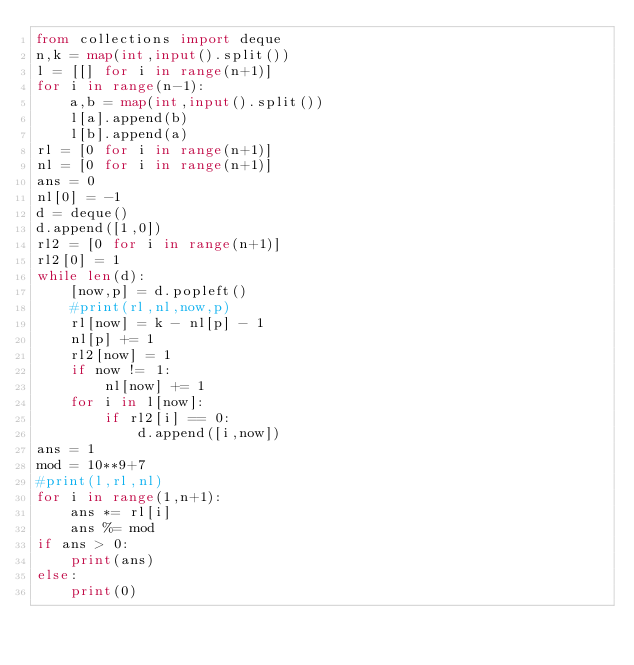<code> <loc_0><loc_0><loc_500><loc_500><_Python_>from collections import deque
n,k = map(int,input().split())
l = [[] for i in range(n+1)]
for i in range(n-1):
    a,b = map(int,input().split())
    l[a].append(b)
    l[b].append(a)
rl = [0 for i in range(n+1)]
nl = [0 for i in range(n+1)]
ans = 0
nl[0] = -1
d = deque()
d.append([1,0])
rl2 = [0 for i in range(n+1)]
rl2[0] = 1
while len(d):
    [now,p] = d.popleft()
    #print(rl,nl,now,p)
    rl[now] = k - nl[p] - 1
    nl[p] += 1
    rl2[now] = 1
    if now != 1:
        nl[now] += 1
    for i in l[now]:
        if rl2[i] == 0:
            d.append([i,now])
ans = 1
mod = 10**9+7
#print(l,rl,nl)
for i in range(1,n+1):
    ans *= rl[i]
    ans %= mod
if ans > 0:
    print(ans)
else:
    print(0)</code> 